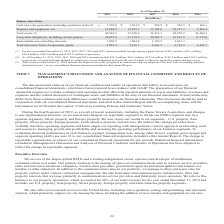According to American Tower Corporation's financial document, Why was Right-of-use asset included in total assets? adoption of the new lease accounting standard described in note 1 to our consolidated financial statements included in this Annual Report. The document states: "ht-of-use asset recognized in connection with our adoption of the new lease accounting standard described in note 1 to our consolidated financial stat..." Also, What was the amount of net property and equipment in 2015? According to the financial document, 9,866.4 (in millions). The relevant text states: "quipment, net 12,084.4 11,247.1 11,101.0 10,517.3 9,866.4..." Also, What were the Redeemable noncontrolling interests in 2019? According to the financial document, 1,096.5 (in millions). The relevant text states: "Redeemable noncontrolling interests 1,096.5 1,004.8 1,126.2 1,091.3 —..." Also, can you calculate: What was the change in Long-term obligations, including current portion between 2018 and 2019? Based on the calculation: 24,055.4-21,159.9, the result is 2895.5 (in millions). This is based on the information: "Long-term obligations, including current portion 24,055.4 21,159.9 20,205.1 18,533.5 17,119.0 m obligations, including current portion 24,055.4 21,159.9 20,205.1 18,533.5 17,119.0..." The key data points involved are: 21,159.9, 24,055.4. Also, can you calculate: What was the percentage change in Total American Tower Corporation equity between 2015 and 2016? To answer this question, I need to perform calculations using the financial data. The calculation is: (6,763.9-6,651.7)/6,651.7, which equals 1.69 (percentage). This is based on the information: "orporation equity 5,055.4 5,336.1 6,241.5 6,763.9 6,651.7 Tower Corporation equity 5,055.4 5,336.1 6,241.5 6,763.9 6,651.7..." The key data points involved are: 6,651.7, 6,763.9. Also, can you calculate: What was the change in total assets between 2017 and 2018? Based on the calculation: 33,010.4-33,214.3, the result is -203.9 (in millions). This is based on the information: "Total assets (3) 42,801.6 33,010.4 33,214.3 30,879.2 26,904.3 Total assets (3) 42,801.6 33,010.4 33,214.3 30,879.2 26,904.3..." The key data points involved are: 33,010.4, 33,214.3. 